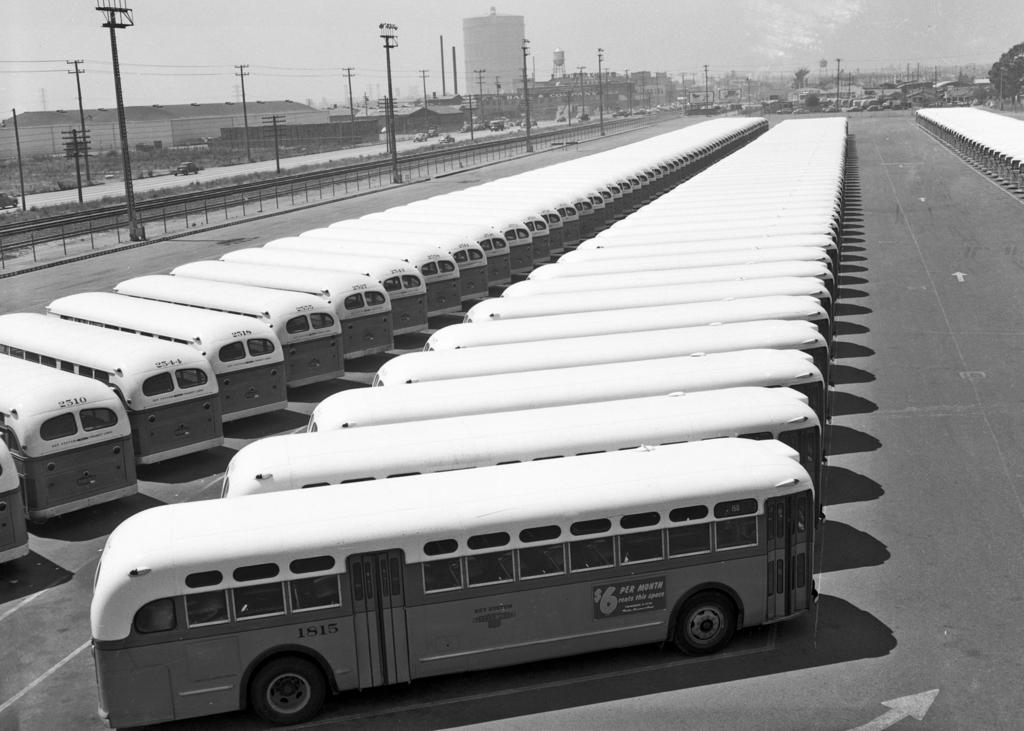What type of vehicles can be seen on the road in the image? There are buses on the road in the image. What structures are present in the image besides the buses? There are poles and buildings in the image. What can be seen in the background of the image? The sky is visible in the background of the image. Can you see a group of sailors on the buses in the image? There is no mention of sailors or any group of people in the image; it only features buses, poles, buildings, and the sky. 